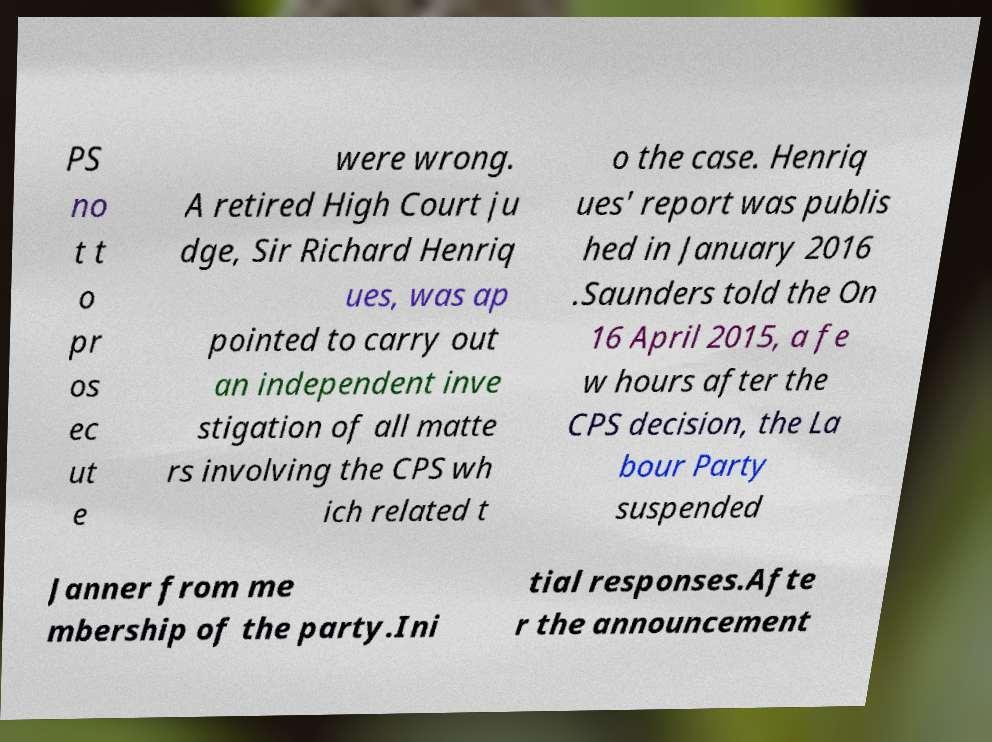For documentation purposes, I need the text within this image transcribed. Could you provide that? PS no t t o pr os ec ut e were wrong. A retired High Court ju dge, Sir Richard Henriq ues, was ap pointed to carry out an independent inve stigation of all matte rs involving the CPS wh ich related t o the case. Henriq ues' report was publis hed in January 2016 .Saunders told the On 16 April 2015, a fe w hours after the CPS decision, the La bour Party suspended Janner from me mbership of the party.Ini tial responses.Afte r the announcement 